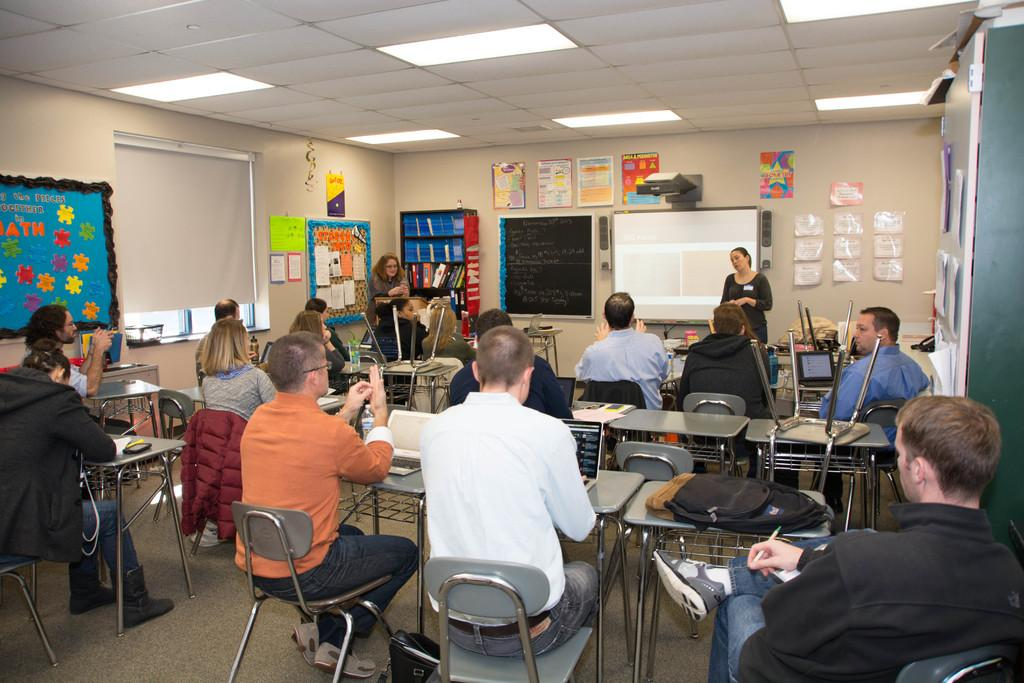What are the people in the image doing? The people in the image are sitting on chairs at a table. What is the woman standing nearby doing? The woman standing nearby is being listened to by the people at the table. What can be seen on the wall in the image? There is a screen and posters on the wall. What type of nose can be seen on the insect in the image? There is no insect present in the image, so there is no nose to describe. What activity are the people participating in while sitting at the table? The provided facts do not specify the activity the people are participating in, so we cannot answer this question definitively. 